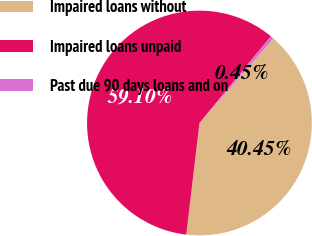Convert chart to OTSL. <chart><loc_0><loc_0><loc_500><loc_500><pie_chart><fcel>Impaired loans without<fcel>Impaired loans unpaid<fcel>Past due 90 days loans and on<nl><fcel>40.45%<fcel>59.09%<fcel>0.45%<nl></chart> 